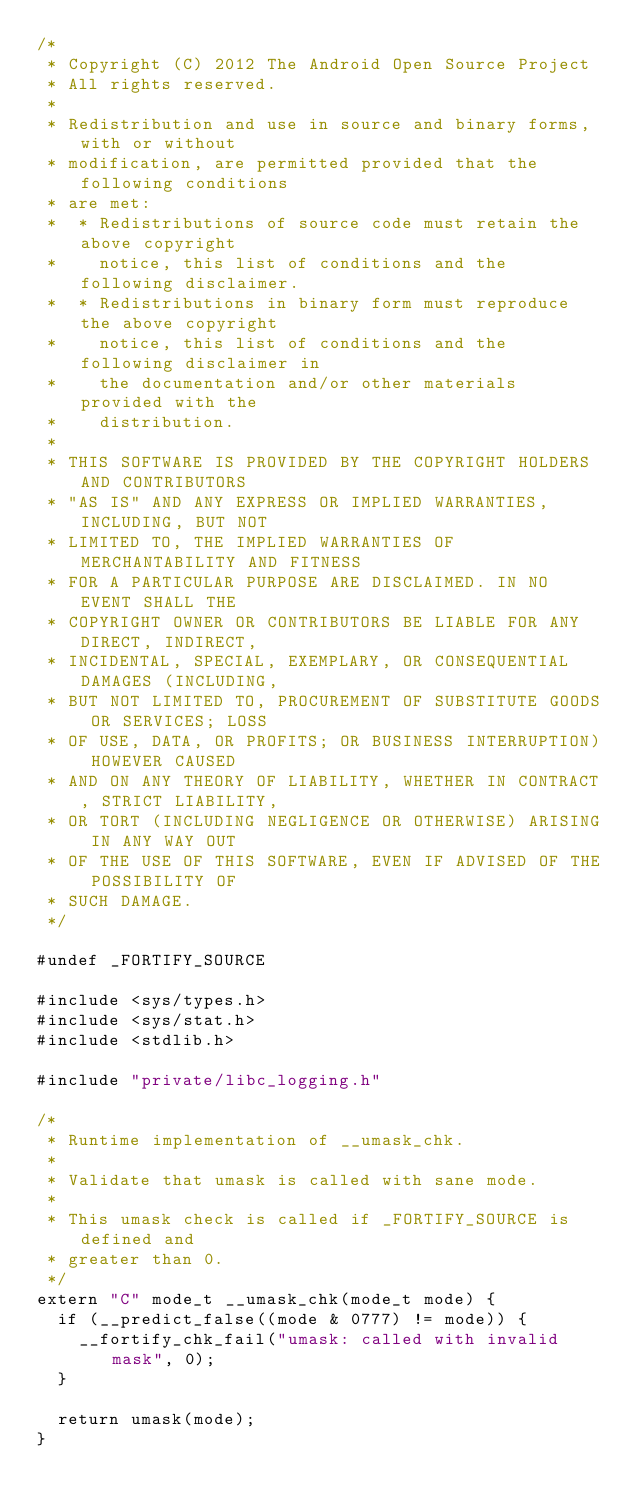Convert code to text. <code><loc_0><loc_0><loc_500><loc_500><_C++_>/*
 * Copyright (C) 2012 The Android Open Source Project
 * All rights reserved.
 *
 * Redistribution and use in source and binary forms, with or without
 * modification, are permitted provided that the following conditions
 * are met:
 *  * Redistributions of source code must retain the above copyright
 *    notice, this list of conditions and the following disclaimer.
 *  * Redistributions in binary form must reproduce the above copyright
 *    notice, this list of conditions and the following disclaimer in
 *    the documentation and/or other materials provided with the
 *    distribution.
 *
 * THIS SOFTWARE IS PROVIDED BY THE COPYRIGHT HOLDERS AND CONTRIBUTORS
 * "AS IS" AND ANY EXPRESS OR IMPLIED WARRANTIES, INCLUDING, BUT NOT
 * LIMITED TO, THE IMPLIED WARRANTIES OF MERCHANTABILITY AND FITNESS
 * FOR A PARTICULAR PURPOSE ARE DISCLAIMED. IN NO EVENT SHALL THE
 * COPYRIGHT OWNER OR CONTRIBUTORS BE LIABLE FOR ANY DIRECT, INDIRECT,
 * INCIDENTAL, SPECIAL, EXEMPLARY, OR CONSEQUENTIAL DAMAGES (INCLUDING,
 * BUT NOT LIMITED TO, PROCUREMENT OF SUBSTITUTE GOODS OR SERVICES; LOSS
 * OF USE, DATA, OR PROFITS; OR BUSINESS INTERRUPTION) HOWEVER CAUSED
 * AND ON ANY THEORY OF LIABILITY, WHETHER IN CONTRACT, STRICT LIABILITY,
 * OR TORT (INCLUDING NEGLIGENCE OR OTHERWISE) ARISING IN ANY WAY OUT
 * OF THE USE OF THIS SOFTWARE, EVEN IF ADVISED OF THE POSSIBILITY OF
 * SUCH DAMAGE.
 */

#undef _FORTIFY_SOURCE

#include <sys/types.h>
#include <sys/stat.h>
#include <stdlib.h>

#include "private/libc_logging.h"

/*
 * Runtime implementation of __umask_chk.
 *
 * Validate that umask is called with sane mode.
 *
 * This umask check is called if _FORTIFY_SOURCE is defined and
 * greater than 0.
 */
extern "C" mode_t __umask_chk(mode_t mode) {
  if (__predict_false((mode & 0777) != mode)) {
    __fortify_chk_fail("umask: called with invalid mask", 0);
  }

  return umask(mode);
}
</code> 